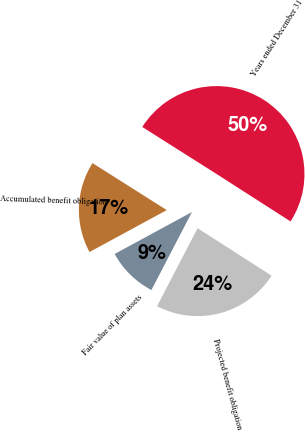Convert chart. <chart><loc_0><loc_0><loc_500><loc_500><pie_chart><fcel>Years ended December 31<fcel>Projected benefit obligation<fcel>Fair value of plan assets<fcel>Accumulated benefit obligation<nl><fcel>50.1%<fcel>23.55%<fcel>9.46%<fcel>16.89%<nl></chart> 